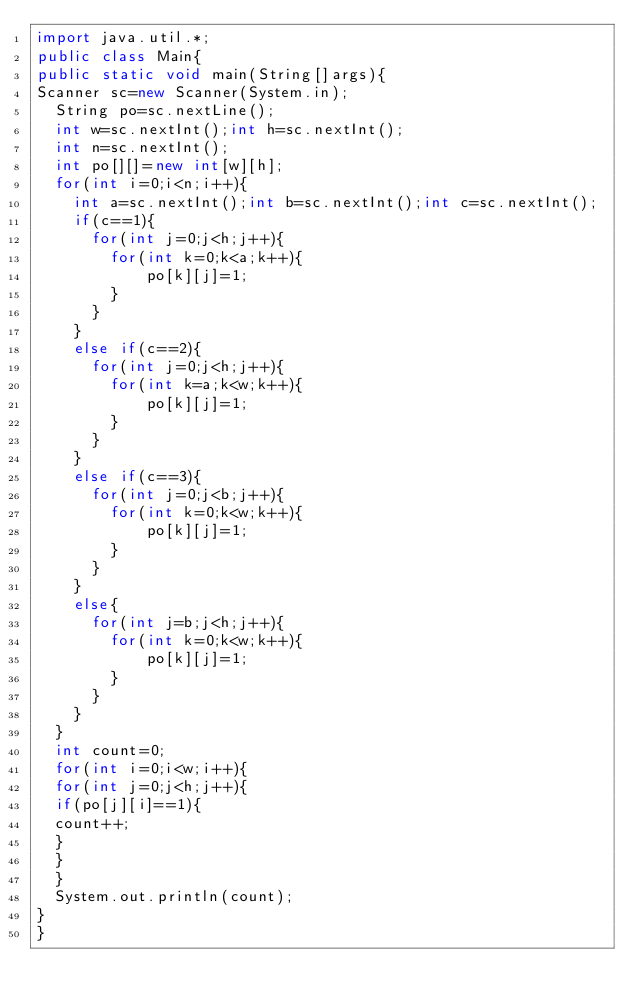Convert code to text. <code><loc_0><loc_0><loc_500><loc_500><_Java_>import java.util.*;
public class Main{
public static void main(String[]args){
Scanner sc=new Scanner(System.in);
  String po=sc.nextLine();
  int w=sc.nextInt();int h=sc.nextInt();
  int n=sc.nextInt();
  int po[][]=new int[w][h];
  for(int i=0;i<n;i++){
  	int a=sc.nextInt();int b=sc.nextInt();int c=sc.nextInt();
    if(c==1){
      for(int j=0;j<h;j++){
      	for(int k=0;k<a;k++){
        	po[k][j]=1;
        }
      }
    }
    else if(c==2){
      for(int j=0;j<h;j++){
      	for(int k=a;k<w;k++){
        	po[k][j]=1;
        }
      }
    }
    else if(c==3){
      for(int j=0;j<b;j++){
      	for(int k=0;k<w;k++){
        	po[k][j]=1;
        }
      }
    }
    else{
      for(int j=b;j<h;j++){
      	for(int k=0;k<w;k++){
        	po[k][j]=1;
        }
      }
    }
  }
  int count=0;
  for(int i=0;i<w;i++){
  for(int j=0;j<h;j++){
  if(po[j][i]==1){
  count++;
  }
  }
  }
  System.out.println(count);
}
}
</code> 